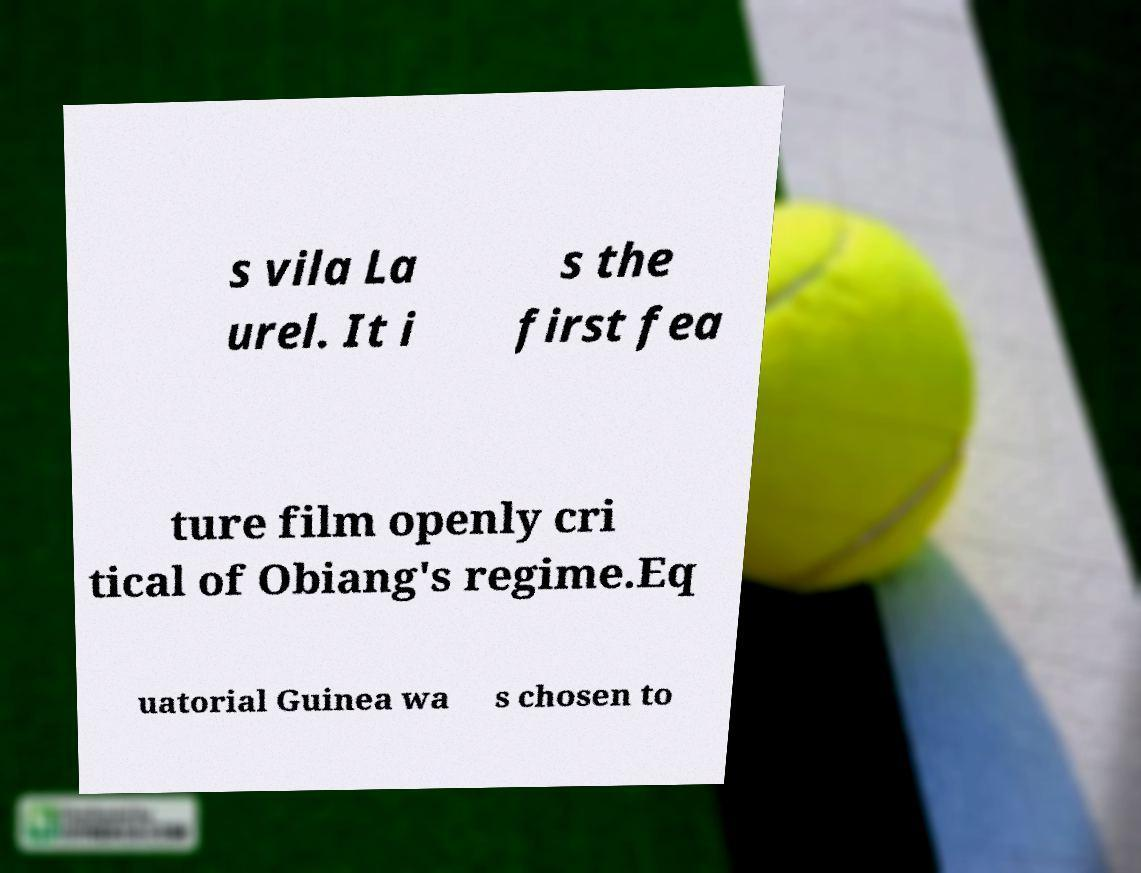Can you accurately transcribe the text from the provided image for me? s vila La urel. It i s the first fea ture film openly cri tical of Obiang's regime.Eq uatorial Guinea wa s chosen to 